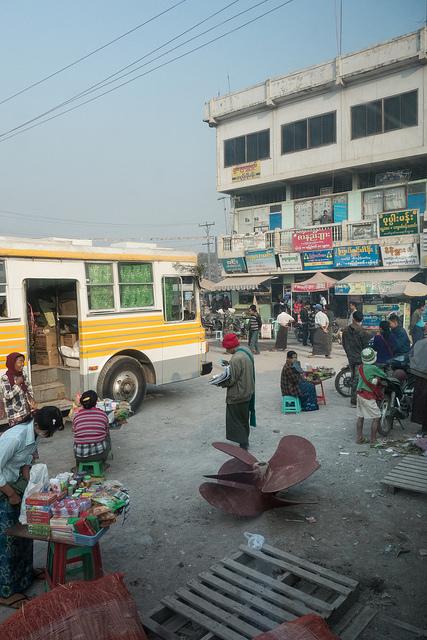Is this a town area?
Be succinct. Yes. How many people do you see?
Quick response, please. 13. Do you see a white car?
Write a very short answer. No. What color is the bus?
Quick response, please. Yellow and white. What are the people in the distance carrying?
Answer briefly. Food. 